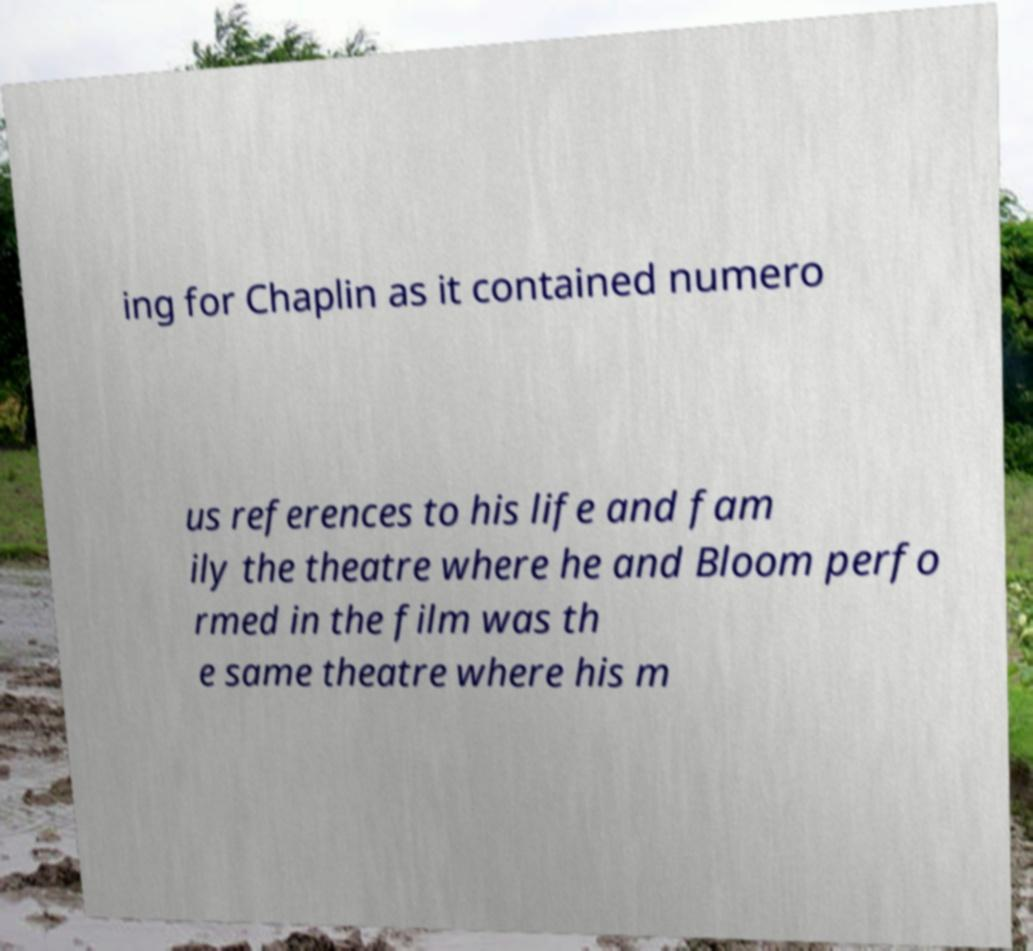For documentation purposes, I need the text within this image transcribed. Could you provide that? ing for Chaplin as it contained numero us references to his life and fam ily the theatre where he and Bloom perfo rmed in the film was th e same theatre where his m 